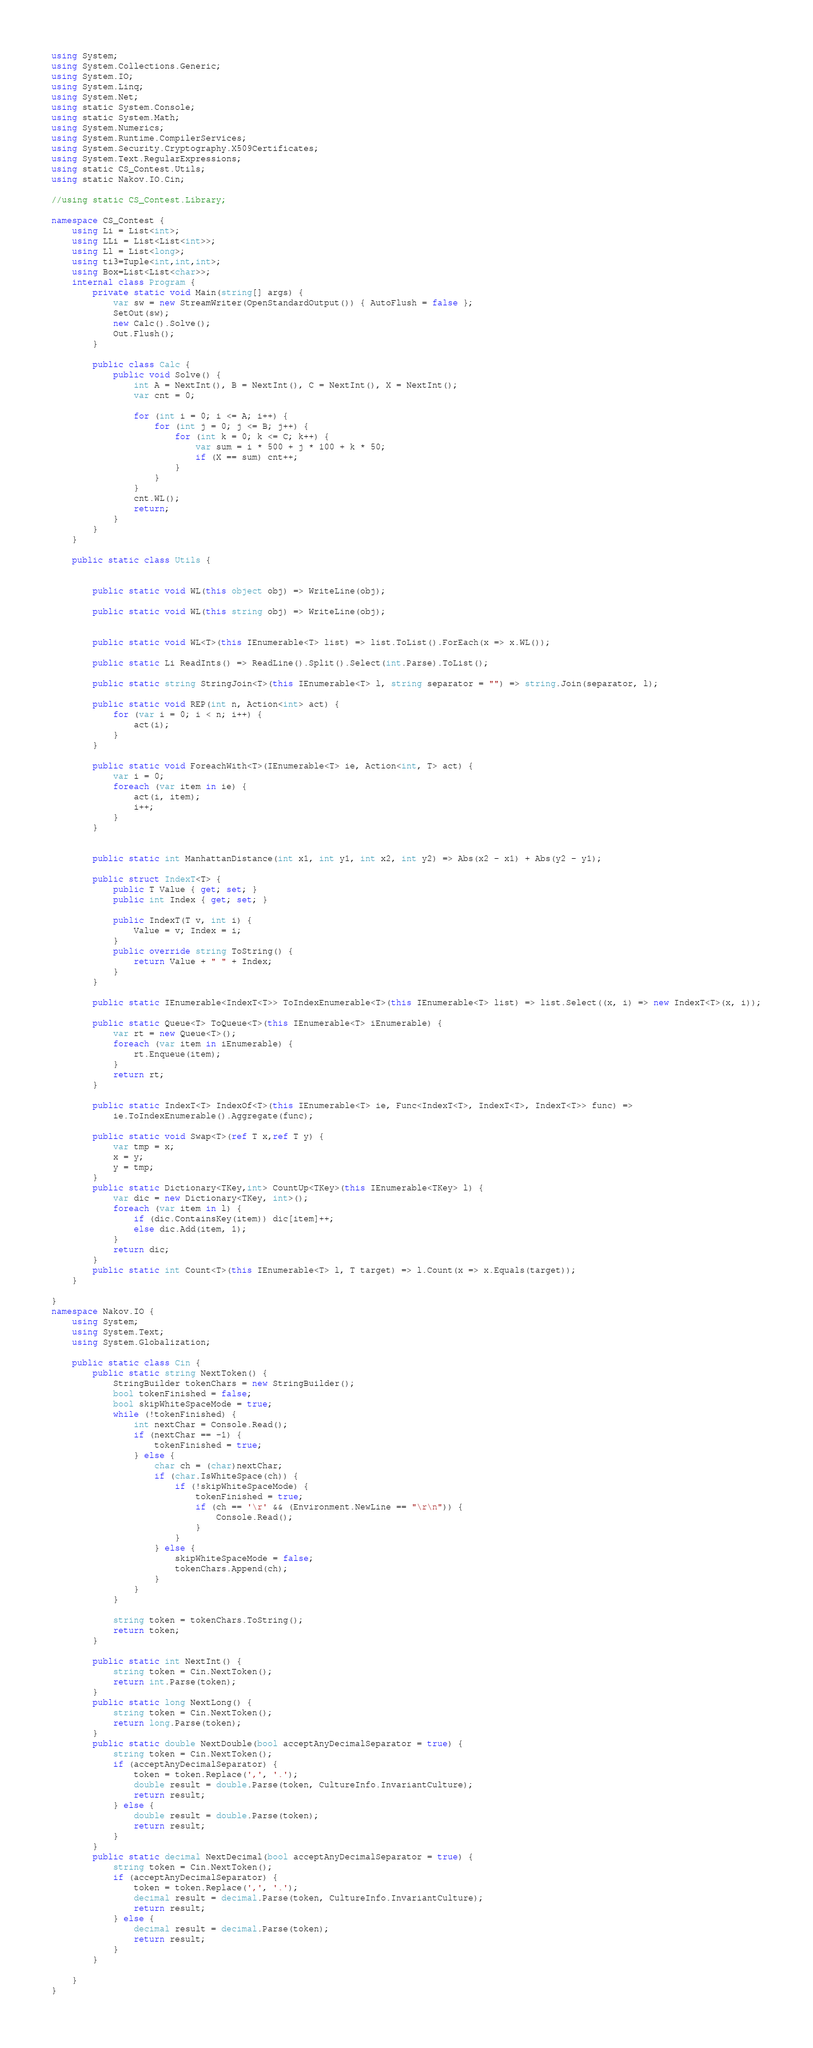Convert code to text. <code><loc_0><loc_0><loc_500><loc_500><_C#_>using System;
using System.Collections.Generic;
using System.IO;
using System.Linq;
using System.Net;
using static System.Console;
using static System.Math;
using System.Numerics;
using System.Runtime.CompilerServices;
using System.Security.Cryptography.X509Certificates;
using System.Text.RegularExpressions;
using static CS_Contest.Utils;
using static Nakov.IO.Cin;

//using static CS_Contest.Library;

namespace CS_Contest {
	using Li = List<int>;
	using LLi = List<List<int>>;
	using Ll = List<long>;
	using ti3=Tuple<int,int,int>;
	using Box=List<List<char>>;
	internal class Program {
		private static void Main(string[] args) {
			var sw = new StreamWriter(OpenStandardOutput()) { AutoFlush = false };
			SetOut(sw);
			new Calc().Solve();
			Out.Flush();
		}

		public class Calc {
			public void Solve() {
				int A = NextInt(), B = NextInt(), C = NextInt(), X = NextInt();
				var cnt = 0;

				for (int i = 0; i <= A; i++) {
					for (int j = 0; j <= B; j++) {
						for (int k = 0; k <= C; k++) {
							var sum = i * 500 + j * 100 + k * 50;
							if (X == sum) cnt++;
						}
					}
				}
				cnt.WL();
				return;
			}
		}
	}

	public static class Utils {

	
		public static void WL(this object obj) => WriteLine(obj);

		public static void WL(this string obj) => WriteLine(obj);


		public static void WL<T>(this IEnumerable<T> list) => list.ToList().ForEach(x => x.WL());

		public static Li ReadInts() => ReadLine().Split().Select(int.Parse).ToList();

		public static string StringJoin<T>(this IEnumerable<T> l, string separator = "") => string.Join(separator, l);

		public static void REP(int n, Action<int> act) {
			for (var i = 0; i < n; i++) {
				act(i);
			}
		}

		public static void ForeachWith<T>(IEnumerable<T> ie, Action<int, T> act) {
			var i = 0;
			foreach (var item in ie) {
				act(i, item);
				i++;
			}
		}


		public static int ManhattanDistance(int x1, int y1, int x2, int y2) => Abs(x2 - x1) + Abs(y2 - y1);

		public struct IndexT<T> {
			public T Value { get; set; }
			public int Index { get; set; }

			public IndexT(T v, int i) {
				Value = v; Index = i;
			}
			public override string ToString() {
				return Value + " " + Index;
			}
		}

		public static IEnumerable<IndexT<T>> ToIndexEnumerable<T>(this IEnumerable<T> list) => list.Select((x, i) => new IndexT<T>(x, i));

		public static Queue<T> ToQueue<T>(this IEnumerable<T> iEnumerable) {
			var rt = new Queue<T>();
			foreach (var item in iEnumerable) {
				rt.Enqueue(item);
			}
			return rt;
		}

		public static IndexT<T> IndexOf<T>(this IEnumerable<T> ie, Func<IndexT<T>, IndexT<T>, IndexT<T>> func) =>
			ie.ToIndexEnumerable().Aggregate(func);

		public static void Swap<T>(ref T x,ref T y) {
			var tmp = x;
			x = y;
			y = tmp;
		}
		public static Dictionary<TKey,int> CountUp<TKey>(this IEnumerable<TKey> l) {
			var dic = new Dictionary<TKey, int>();
			foreach (var item in l) {
				if (dic.ContainsKey(item)) dic[item]++;
				else dic.Add(item, 1);
			}
			return dic;
		}
		public static int Count<T>(this IEnumerable<T> l, T target) => l.Count(x => x.Equals(target));
	}

}
namespace Nakov.IO {
	using System;
	using System.Text;
	using System.Globalization;

	public static class Cin {
		public static string NextToken() {
			StringBuilder tokenChars = new StringBuilder();
			bool tokenFinished = false;
			bool skipWhiteSpaceMode = true;
			while (!tokenFinished) {
				int nextChar = Console.Read();
				if (nextChar == -1) {
					tokenFinished = true;
				} else {
					char ch = (char)nextChar;
					if (char.IsWhiteSpace(ch)) {
						if (!skipWhiteSpaceMode) {
							tokenFinished = true;
							if (ch == '\r' && (Environment.NewLine == "\r\n")) {
								Console.Read();
							}
						}
					} else {
						skipWhiteSpaceMode = false;
						tokenChars.Append(ch);
					}
				}
			}

			string token = tokenChars.ToString();
			return token;
		}

		public static int NextInt() {
			string token = Cin.NextToken();
			return int.Parse(token);
		}
		public static long NextLong() {
			string token = Cin.NextToken();
			return long.Parse(token);
		}
		public static double NextDouble(bool acceptAnyDecimalSeparator = true) {
			string token = Cin.NextToken();
			if (acceptAnyDecimalSeparator) {
				token = token.Replace(',', '.');
				double result = double.Parse(token, CultureInfo.InvariantCulture);
				return result;
			} else {
				double result = double.Parse(token);
				return result;
			}
		}
		public static decimal NextDecimal(bool acceptAnyDecimalSeparator = true) {
			string token = Cin.NextToken();
			if (acceptAnyDecimalSeparator) {
				token = token.Replace(',', '.');
				decimal result = decimal.Parse(token, CultureInfo.InvariantCulture);
				return result;
			} else {
				decimal result = decimal.Parse(token);
				return result;
			}
		}

	}
}</code> 